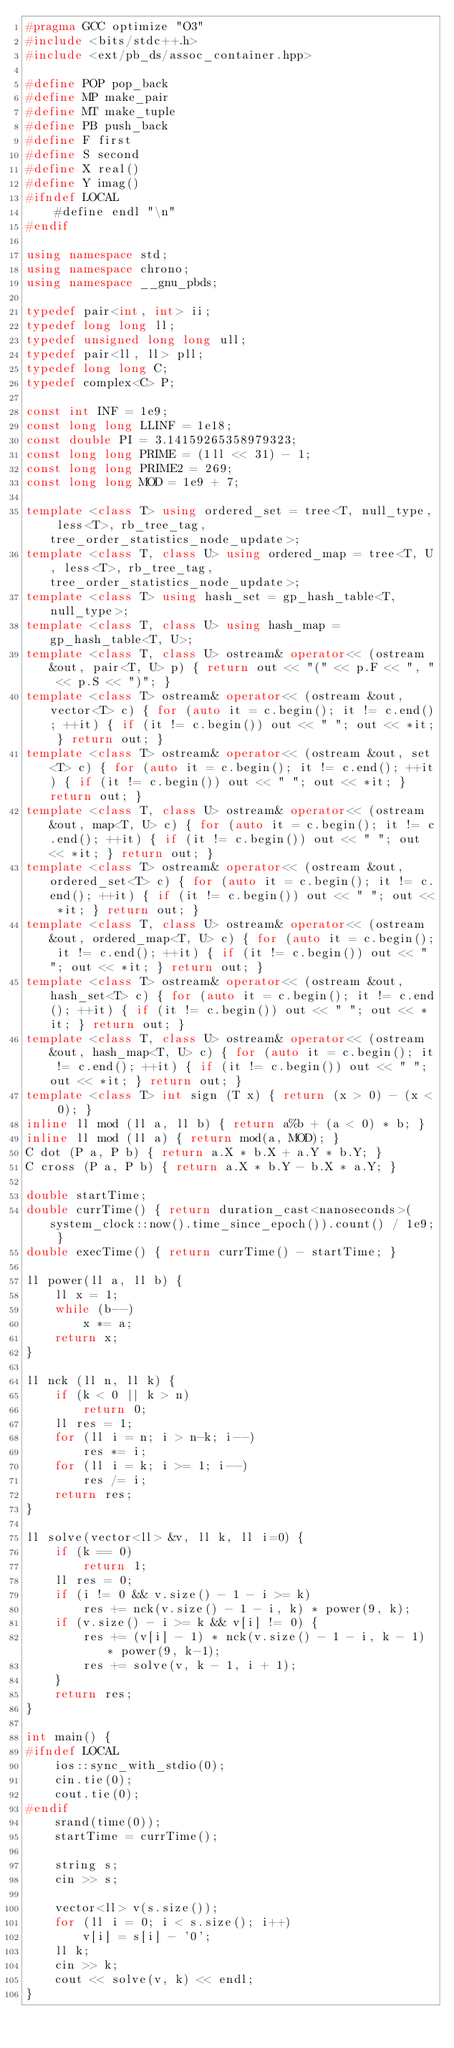Convert code to text. <code><loc_0><loc_0><loc_500><loc_500><_C++_>#pragma GCC optimize "O3"
#include <bits/stdc++.h>
#include <ext/pb_ds/assoc_container.hpp>

#define POP pop_back
#define MP make_pair
#define MT make_tuple
#define PB push_back
#define F first
#define S second
#define X real()
#define Y imag()
#ifndef LOCAL
    #define endl "\n"
#endif

using namespace std;
using namespace chrono;
using namespace __gnu_pbds;

typedef pair<int, int> ii;
typedef long long ll;
typedef unsigned long long ull;
typedef pair<ll, ll> pll;
typedef long long C;
typedef complex<C> P;

const int INF = 1e9;
const long long LLINF = 1e18;
const double PI = 3.14159265358979323;
const long long PRIME = (1ll << 31) - 1;
const long long PRIME2 = 269;
const long long MOD = 1e9 + 7;

template <class T> using ordered_set = tree<T, null_type, less<T>, rb_tree_tag, tree_order_statistics_node_update>;
template <class T, class U> using ordered_map = tree<T, U, less<T>, rb_tree_tag, tree_order_statistics_node_update>;
template <class T> using hash_set = gp_hash_table<T, null_type>;
template <class T, class U> using hash_map = gp_hash_table<T, U>;
template <class T, class U> ostream& operator<< (ostream &out, pair<T, U> p) { return out << "(" << p.F << ", " << p.S << ")"; }
template <class T> ostream& operator<< (ostream &out, vector<T> c) { for (auto it = c.begin(); it != c.end(); ++it) { if (it != c.begin()) out << " "; out << *it; } return out; }
template <class T> ostream& operator<< (ostream &out, set<T> c) { for (auto it = c.begin(); it != c.end(); ++it) { if (it != c.begin()) out << " "; out << *it; } return out; }
template <class T, class U> ostream& operator<< (ostream &out, map<T, U> c) { for (auto it = c.begin(); it != c.end(); ++it) { if (it != c.begin()) out << " "; out << *it; } return out; }
template <class T> ostream& operator<< (ostream &out, ordered_set<T> c) { for (auto it = c.begin(); it != c.end(); ++it) { if (it != c.begin()) out << " "; out << *it; } return out; }
template <class T, class U> ostream& operator<< (ostream &out, ordered_map<T, U> c) { for (auto it = c.begin(); it != c.end(); ++it) { if (it != c.begin()) out << " "; out << *it; } return out; }
template <class T> ostream& operator<< (ostream &out, hash_set<T> c) { for (auto it = c.begin(); it != c.end(); ++it) { if (it != c.begin()) out << " "; out << *it; } return out; }
template <class T, class U> ostream& operator<< (ostream &out, hash_map<T, U> c) { for (auto it = c.begin(); it != c.end(); ++it) { if (it != c.begin()) out << " "; out << *it; } return out; }
template <class T> int sign (T x) { return (x > 0) - (x < 0); }
inline ll mod (ll a, ll b) { return a%b + (a < 0) * b; }
inline ll mod (ll a) { return mod(a, MOD); }
C dot (P a, P b) { return a.X * b.X + a.Y * b.Y; }
C cross (P a, P b) { return a.X * b.Y - b.X * a.Y; }

double startTime;
double currTime() { return duration_cast<nanoseconds>(system_clock::now().time_since_epoch()).count() / 1e9; }
double execTime() { return currTime() - startTime; }

ll power(ll a, ll b) {
    ll x = 1;
    while (b--)
        x *= a;
    return x;
}

ll nck (ll n, ll k) {
    if (k < 0 || k > n)
        return 0;
    ll res = 1;
    for (ll i = n; i > n-k; i--)
        res *= i;
    for (ll i = k; i >= 1; i--)
        res /= i;
    return res;
}

ll solve(vector<ll> &v, ll k, ll i=0) {
    if (k == 0)
        return 1;
    ll res = 0;
    if (i != 0 && v.size() - 1 - i >= k)
        res += nck(v.size() - 1 - i, k) * power(9, k);
    if (v.size() - i >= k && v[i] != 0) {
        res += (v[i] - 1) * nck(v.size() - 1 - i, k - 1) * power(9, k-1);
        res += solve(v, k - 1, i + 1);
    }
    return res;
}

int main() {
#ifndef LOCAL
    ios::sync_with_stdio(0);
    cin.tie(0);
    cout.tie(0);
#endif
    srand(time(0));
    startTime = currTime();

    string s;
    cin >> s;

    vector<ll> v(s.size());
    for (ll i = 0; i < s.size(); i++)
        v[i] = s[i] - '0';
    ll k;
    cin >> k;
    cout << solve(v, k) << endl;
}
</code> 